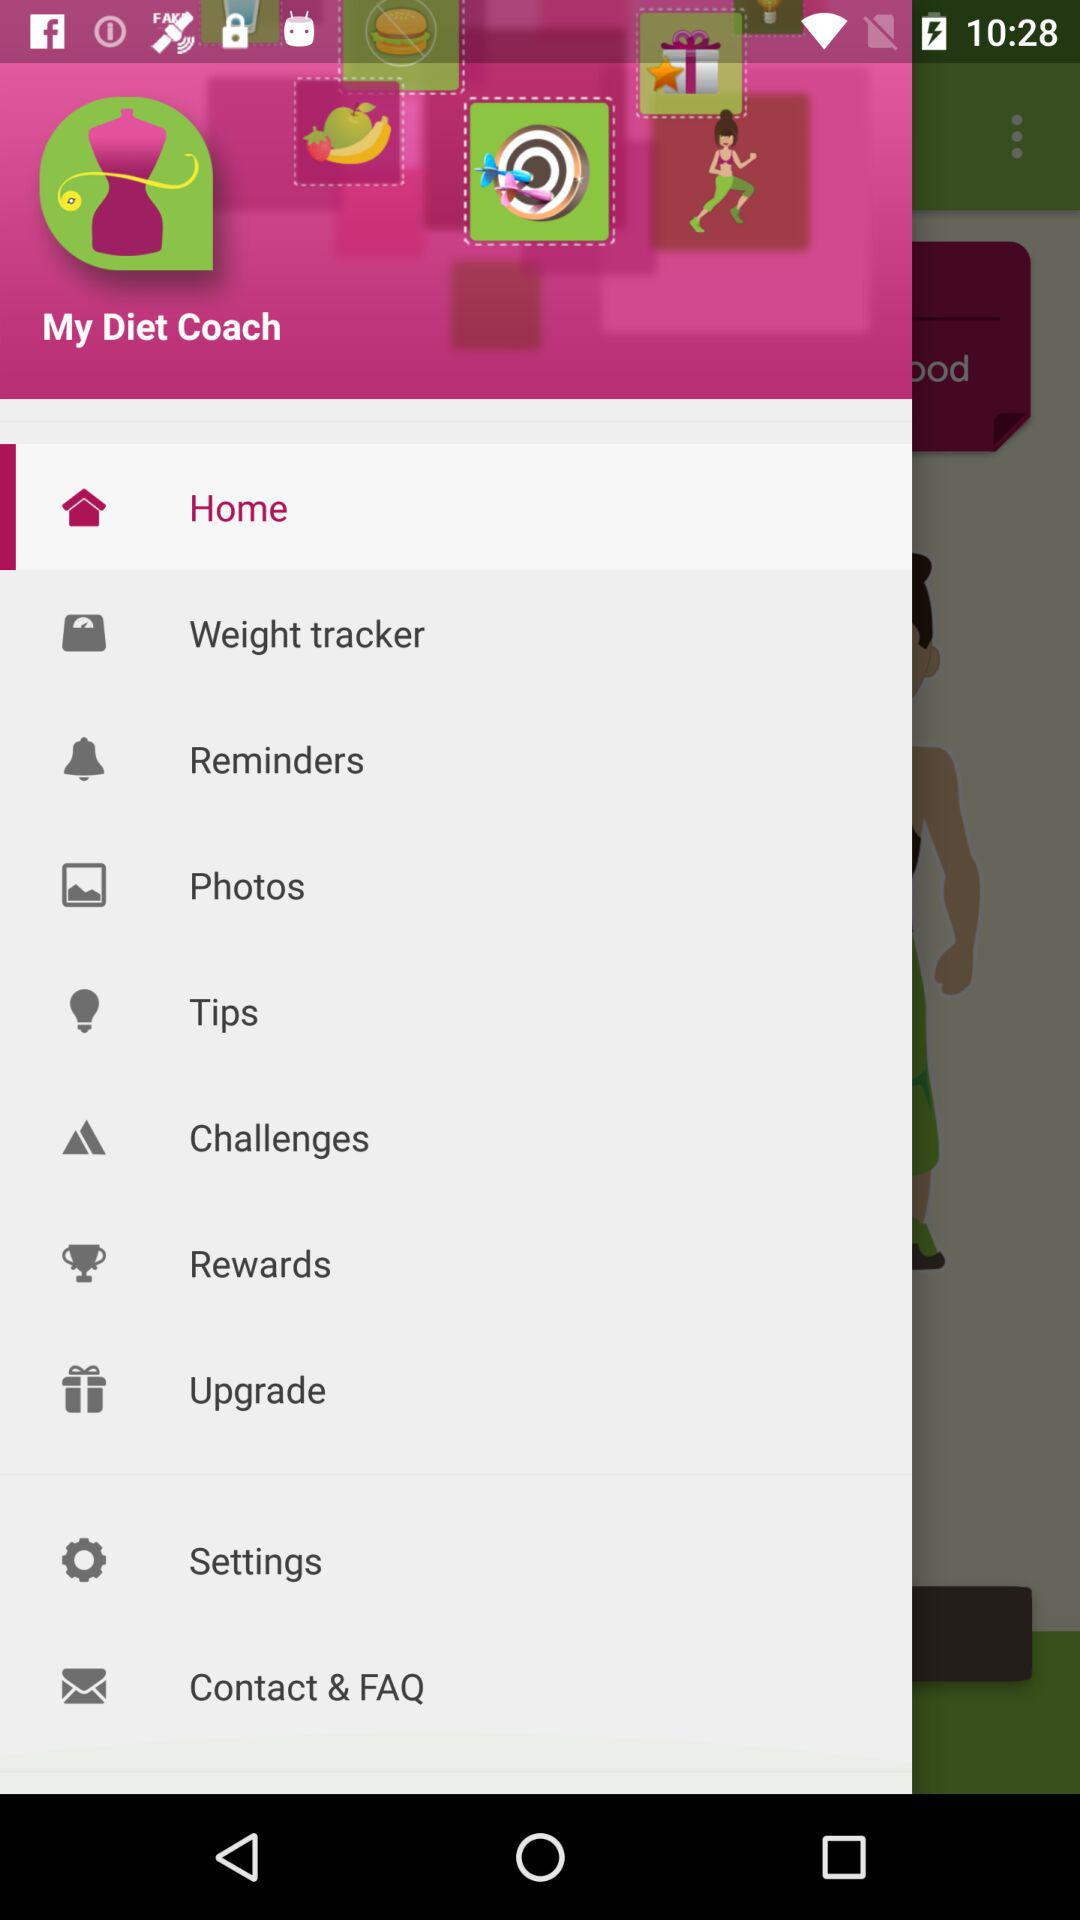What is the name of the application? The name of the application is "My Diet Coach". 